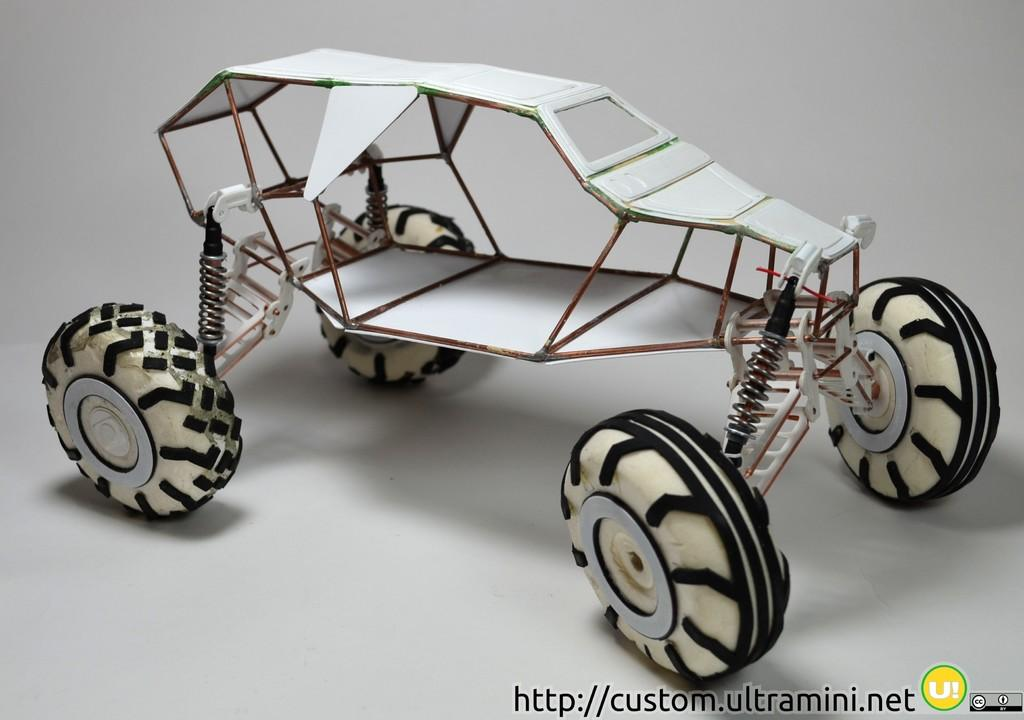What object can be seen in the image that is typically used for play? There is a toy in the image. What type of object is commonly used for transportation and is visible in the image? There are tires in the image. What mechanical component can be seen in the image? There is a metal spring in the image. What color is the surface that the objects are placed on in the image? There is a white surface in the image. Is there any text or logo visible in the image? There is a watermark in the image. What condition is the family in during the image? There is no family present in the image, so it is not possible to determine their condition. 